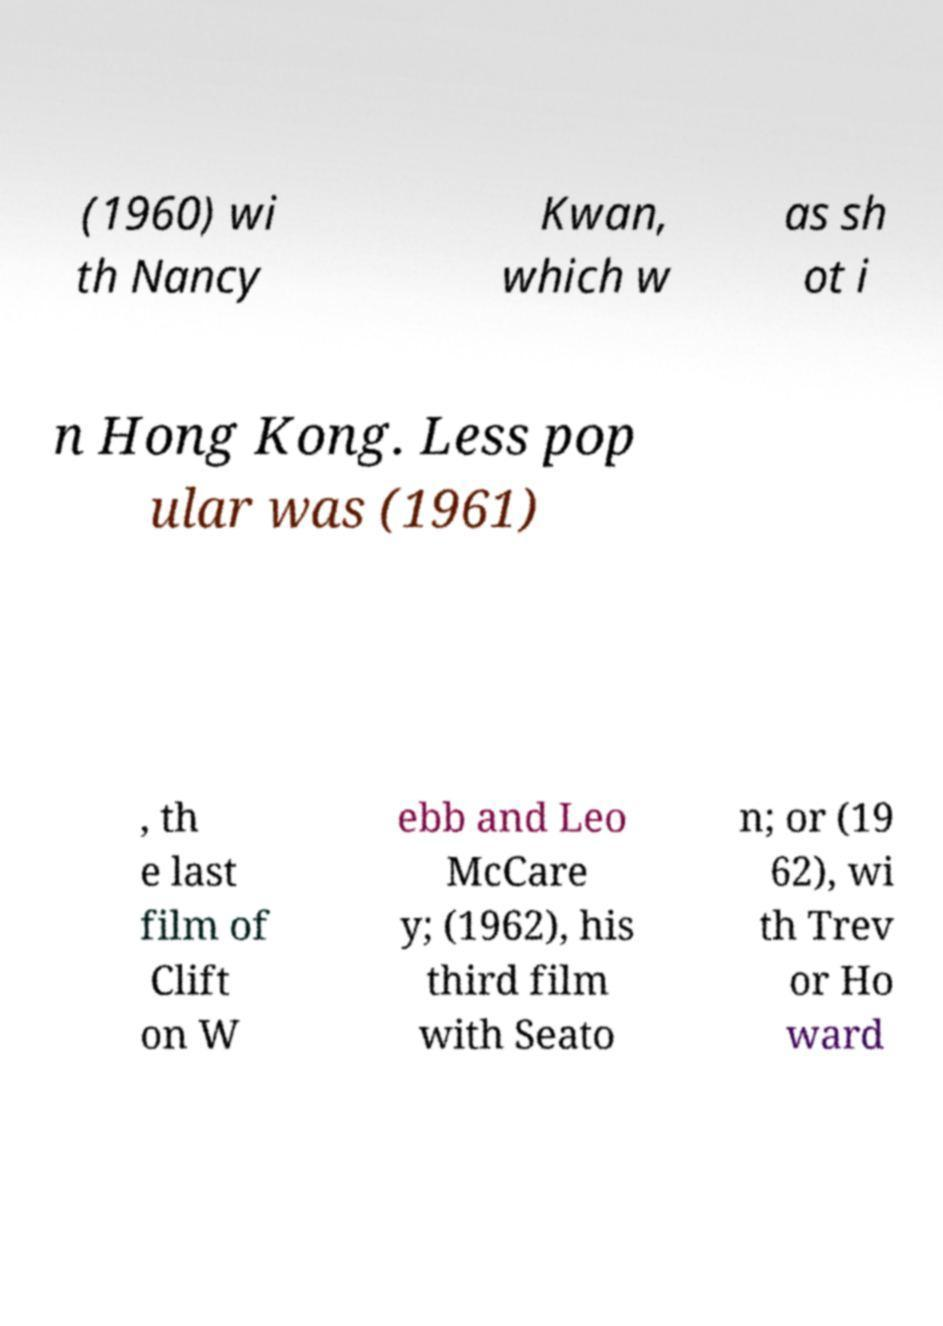What messages or text are displayed in this image? I need them in a readable, typed format. (1960) wi th Nancy Kwan, which w as sh ot i n Hong Kong. Less pop ular was (1961) , th e last film of Clift on W ebb and Leo McCare y; (1962), his third film with Seato n; or (19 62), wi th Trev or Ho ward 